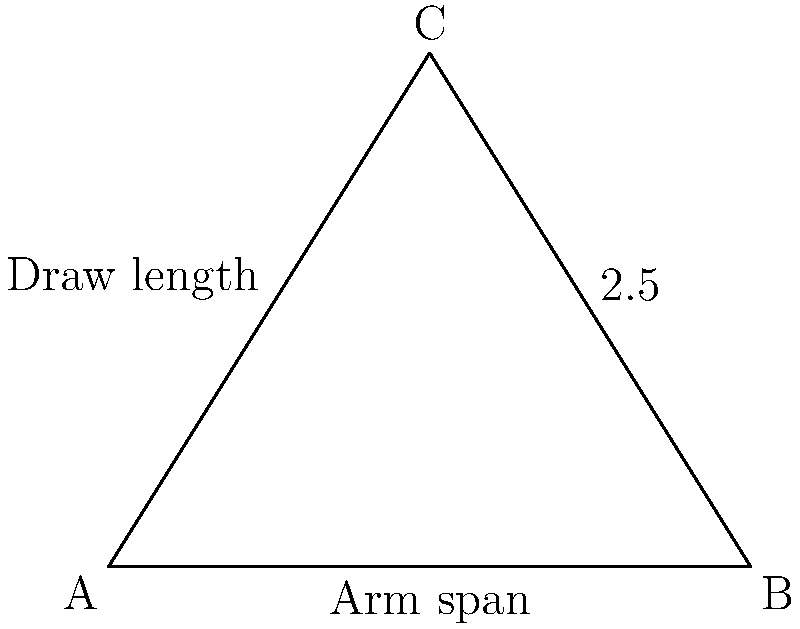In the diagram above, triangle ABC represents an archer's stance and draw. The base AB represents the archer's arm span, and AC represents the ideal draw length. If the ratio of draw length to arm span is 1:2.5, what fraction of the arm span is the ideal draw length? To solve this problem, we'll follow these steps:

1) Let's denote the arm span (AB) as $x$ and the draw length (AC) as $y$.

2) We're given that the ratio of draw length to arm span is 1:2.5. This can be expressed mathematically as:

   $\frac{y}{x} = \frac{1}{2.5}$

3) To find what fraction of the arm span is the ideal draw length, we need to solve this equation for $\frac{y}{x}$.

4) The equation is already in the form we need. We just need to simplify the right side:

   $\frac{y}{x} = \frac{1}{2.5} = \frac{2}{5}$

5) Therefore, the ideal draw length is $\frac{2}{5}$ of the arm span.
Answer: $\frac{2}{5}$ 